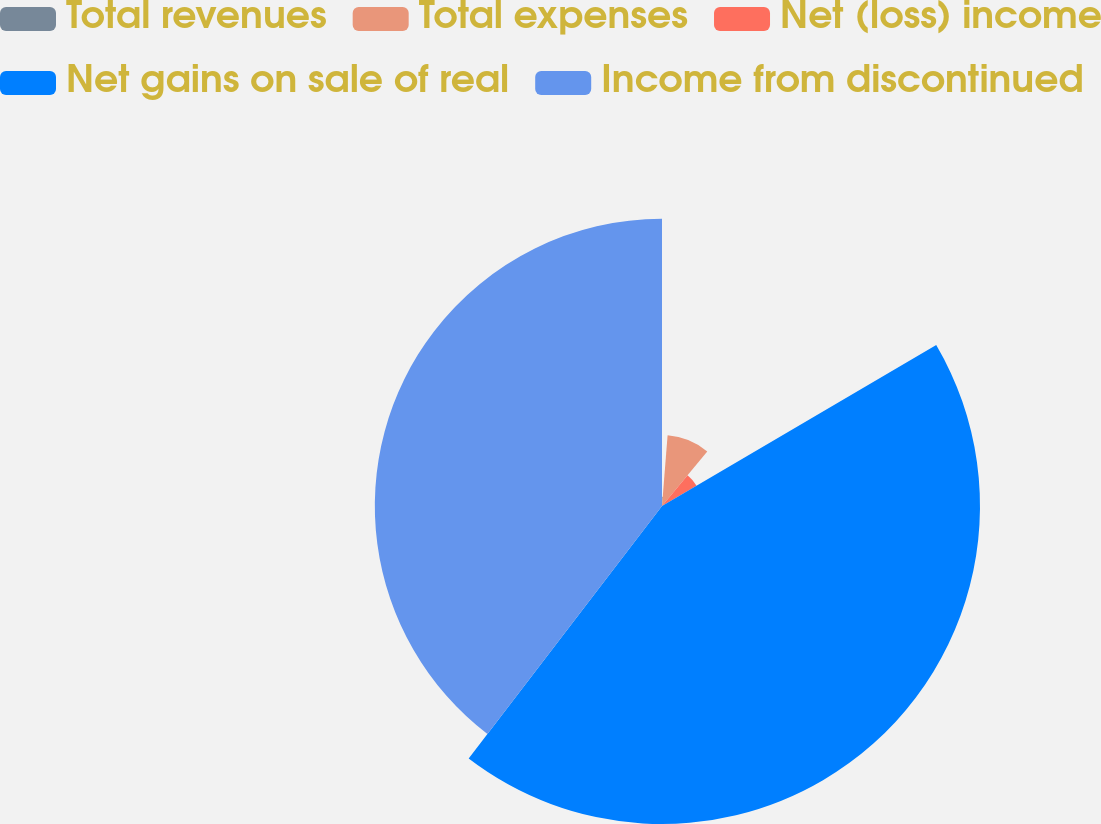Convert chart to OTSL. <chart><loc_0><loc_0><loc_500><loc_500><pie_chart><fcel>Total revenues<fcel>Total expenses<fcel>Net (loss) income<fcel>Net gains on sale of real<fcel>Income from discontinued<nl><fcel>1.26%<fcel>9.77%<fcel>5.52%<fcel>43.85%<fcel>39.6%<nl></chart> 